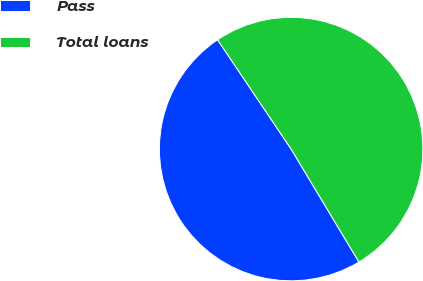Convert chart. <chart><loc_0><loc_0><loc_500><loc_500><pie_chart><fcel>Pass<fcel>Total loans<nl><fcel>49.18%<fcel>50.82%<nl></chart> 